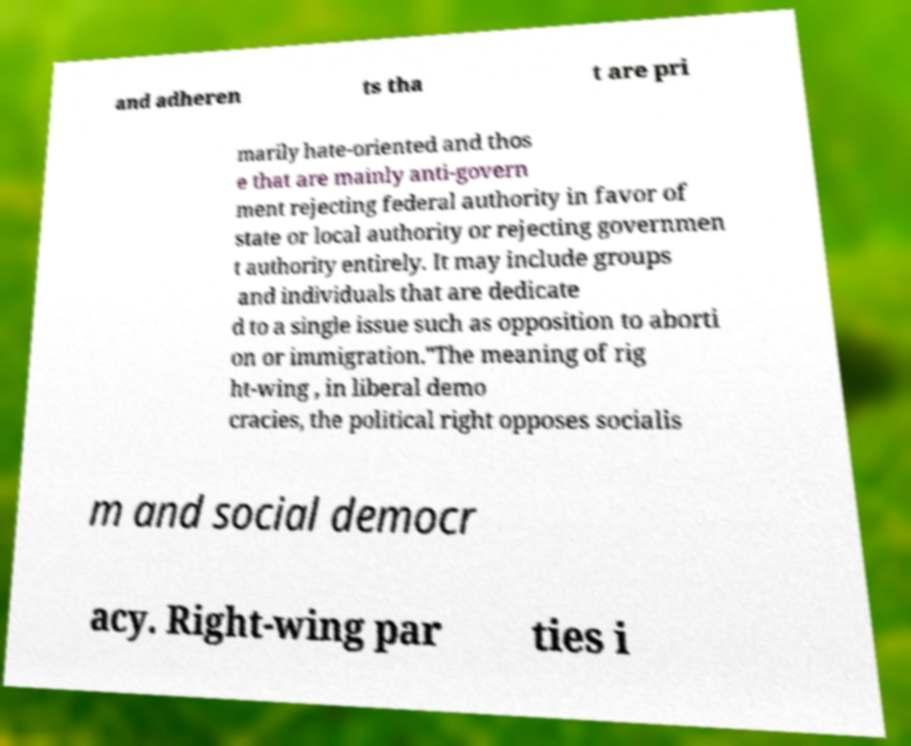There's text embedded in this image that I need extracted. Can you transcribe it verbatim? and adheren ts tha t are pri marily hate-oriented and thos e that are mainly anti-govern ment rejecting federal authority in favor of state or local authority or rejecting governmen t authority entirely. It may include groups and individuals that are dedicate d to a single issue such as opposition to aborti on or immigration."The meaning of rig ht-wing , in liberal demo cracies, the political right opposes socialis m and social democr acy. Right-wing par ties i 